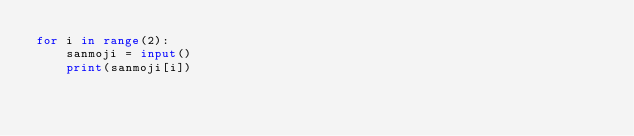<code> <loc_0><loc_0><loc_500><loc_500><_Python_>for i in range(2):
    sanmoji = input()
    print(sanmoji[i])</code> 